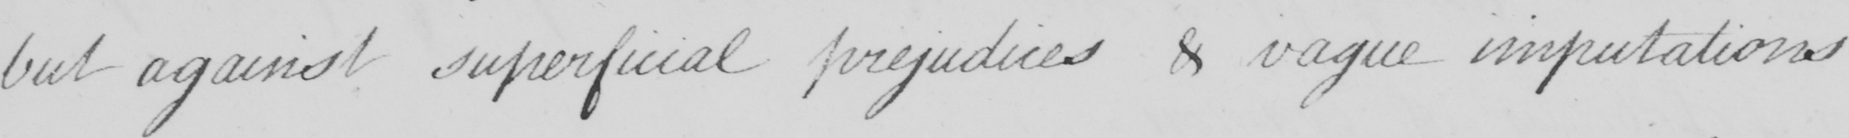Can you read and transcribe this handwriting? but against superficial prejudices & vague imputations 